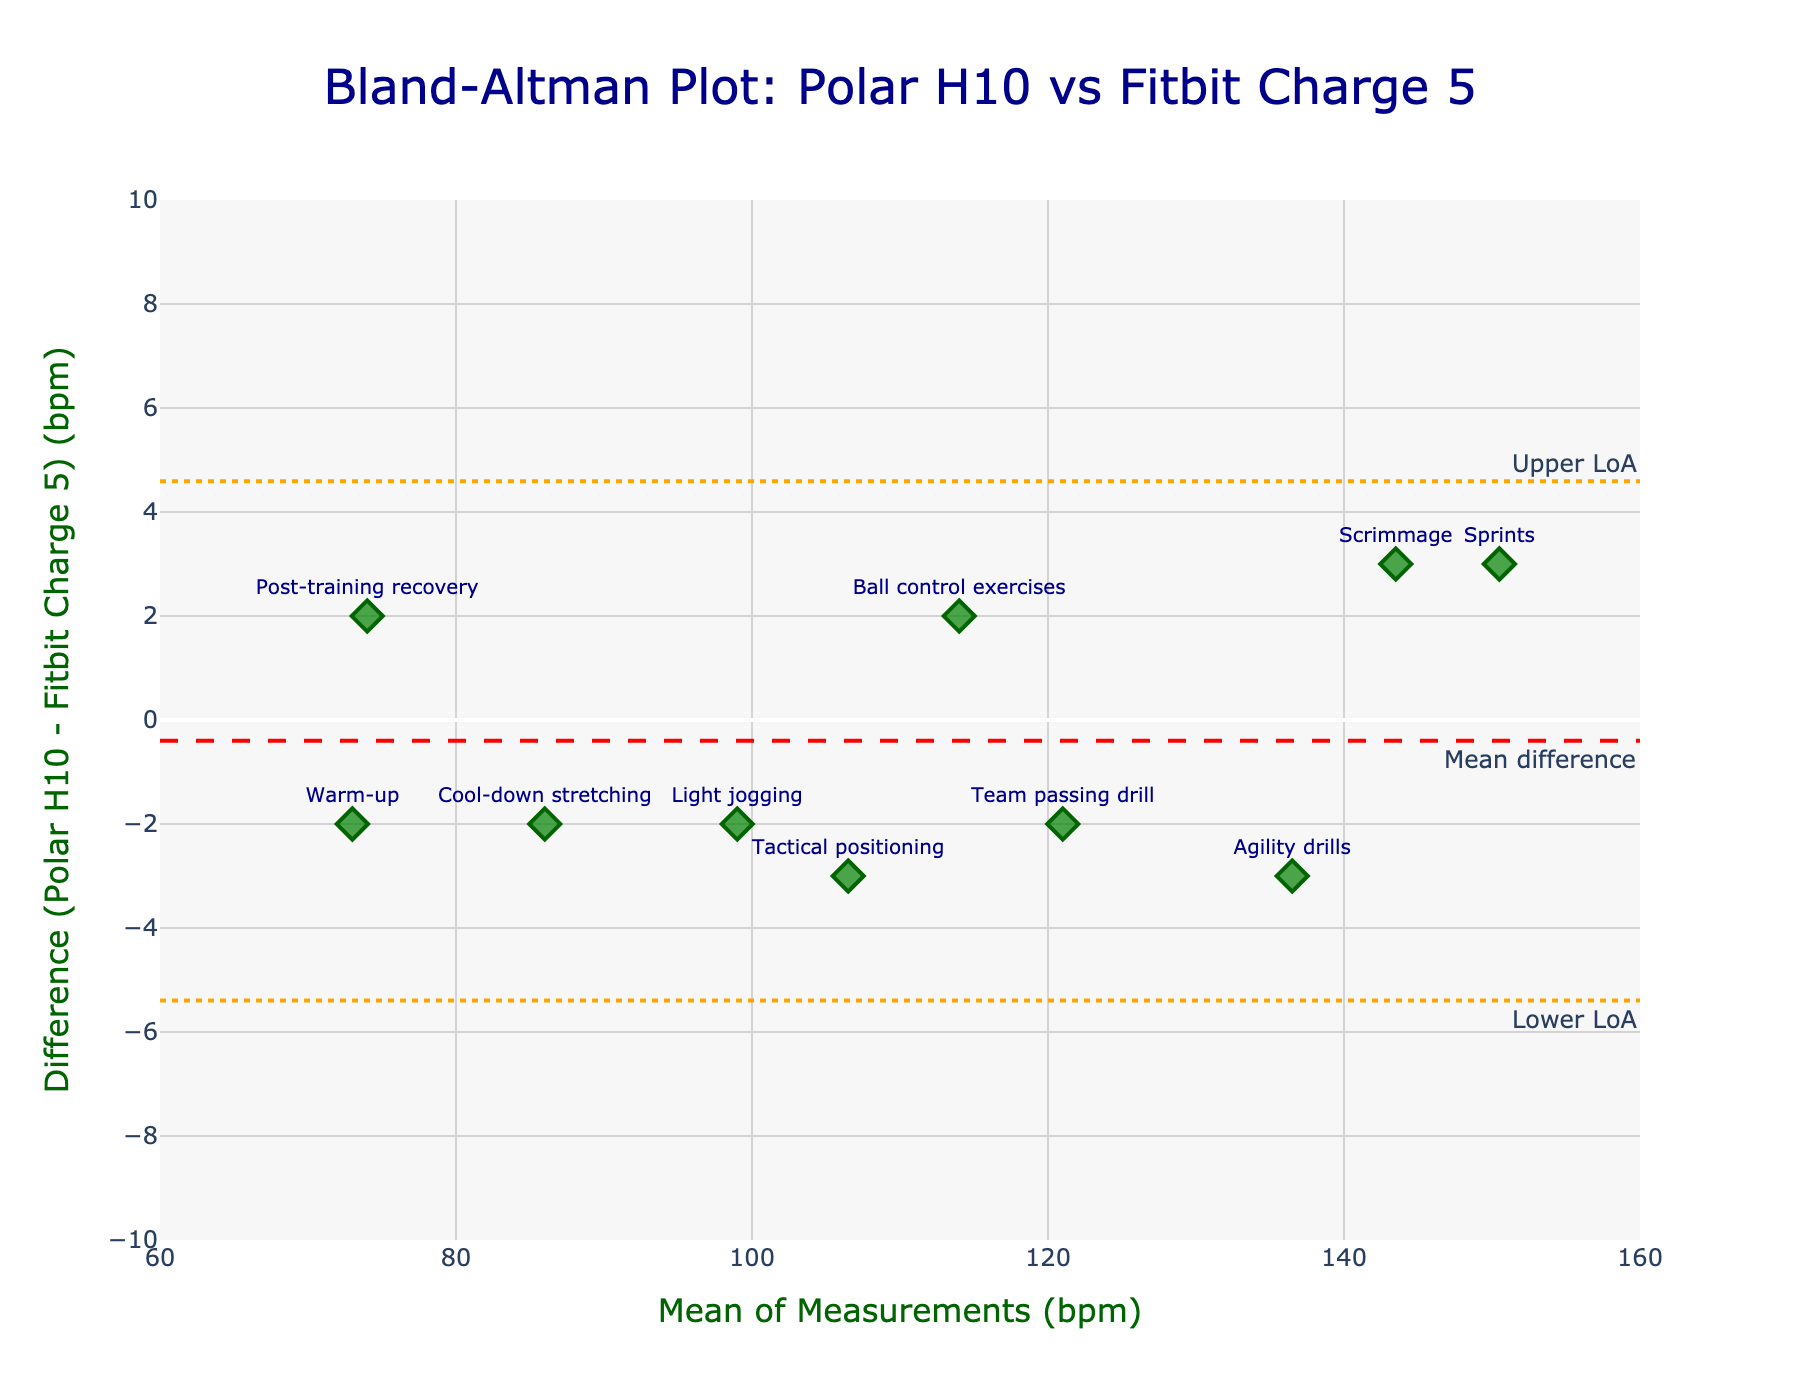What is the title of the plot? The title is prominently displayed at the top of the figure in dark blue.
Answer: Bland-Altman Plot: Polar H10 vs Fitbit Charge 5 How many data points are shown on the scatter plot? Count the number of markers (diamonds) on the plot, each representing different training sessions.
Answer: 10 What are the x-axis and y-axis titles? These titles are displayed beneath the x-axis and to the left of the y-axis. The x-axis title is "Mean of Measurements (bpm)" and the y-axis title is "Difference (Polar H10 - Fitbit Charge 5) (bpm)".
Answer: Mean of Measurements (bpm); Difference (Polar H10 - Fitbit Charge 5) (bpm) What is the mean difference between the two devices? The mean difference line is indicated in red with the annotation "Mean difference" in the legend. The y-value where this line crosses the y-axis represents the mean difference.
Answer: Approx. -0.1 bpm What are the upper and lower limits of agreement (LoA)? The upper and lower limits are marked by dashed orange lines with annotations "Upper LoA" and "Lower LoA".
Answer: Upper LoA: Approx. 3.7 bpm, Lower LoA: Approx. -3.9 bpm Which session shows the largest positive difference between the two monitors? Look for the highest point above the mean difference line on the scatter plot and read the corresponding session label.
Answer: Light jogging Which session shows the largest negative difference between the two monitors? Look for the lowest point below the mean difference line on the scatter plot and read the corresponding session label.
Answer: Sprints What session shows no difference between the two monitors? Find the point on the y-axis where the difference is zero and read the corresponding session label.
Answer: Not applicable, no sessions show zero difference Is there any session that falls outside the limits of agreement? Check if any points fall outside the upper and lower LoA dashed lines.
Answer: No If one prefers an agreement within ±2 bpm between devices, how many sessions fall outside this range? Count the number of data points that are either above 2 bpm or below -2 bpm on the y-axis to determine sessions that fall outside the ±2 bpm range.
Answer: 2 sessions 